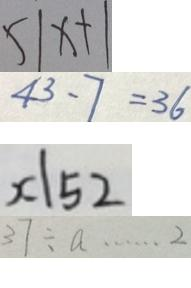Convert formula to latex. <formula><loc_0><loc_0><loc_500><loc_500>5 \vert x + \vert 
 4 3 - 7 = 3 6 
 x \vert 5 2 
 3 7 \div a \cdots 2</formula> 